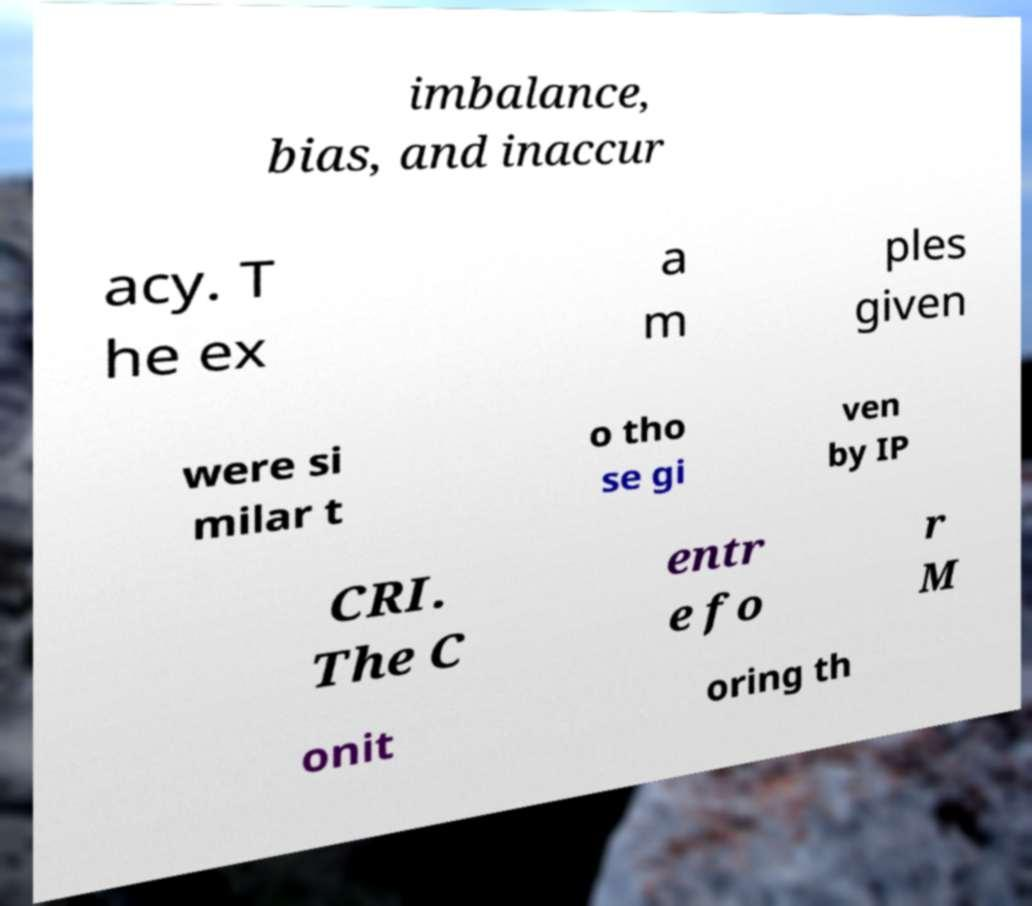Can you accurately transcribe the text from the provided image for me? imbalance, bias, and inaccur acy. T he ex a m ples given were si milar t o tho se gi ven by IP CRI. The C entr e fo r M onit oring th 